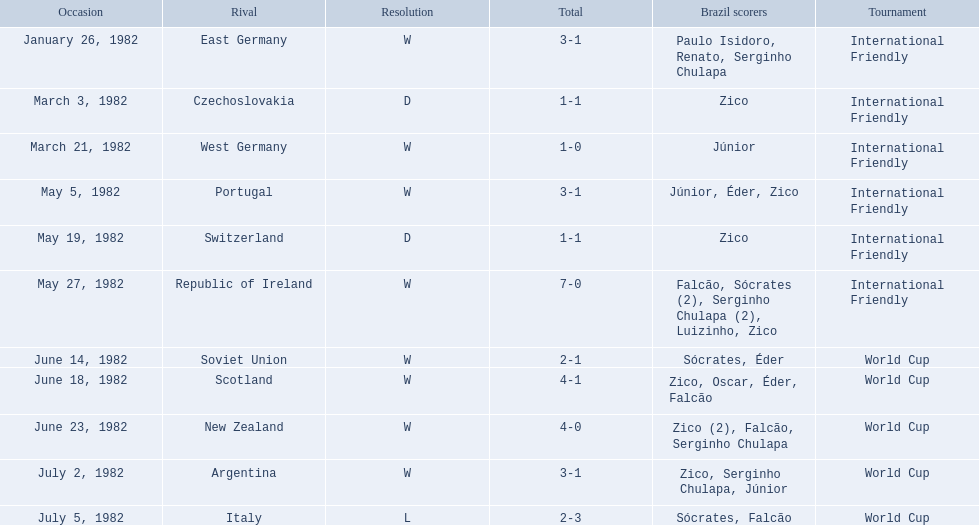How many goals did brazil score against the soviet union? 2-1. How many goals did brazil score against portugal? 3-1. Did brazil score more goals against portugal or the soviet union? Portugal. 